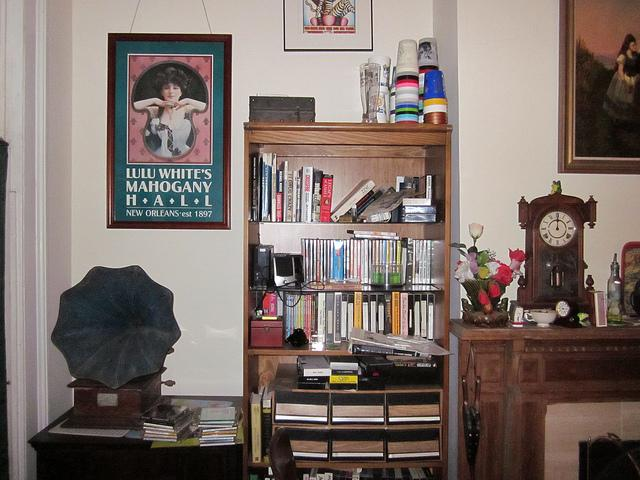Where is this bookshelf located?

Choices:
A) home
B) courtroom
C) store
D) library home 